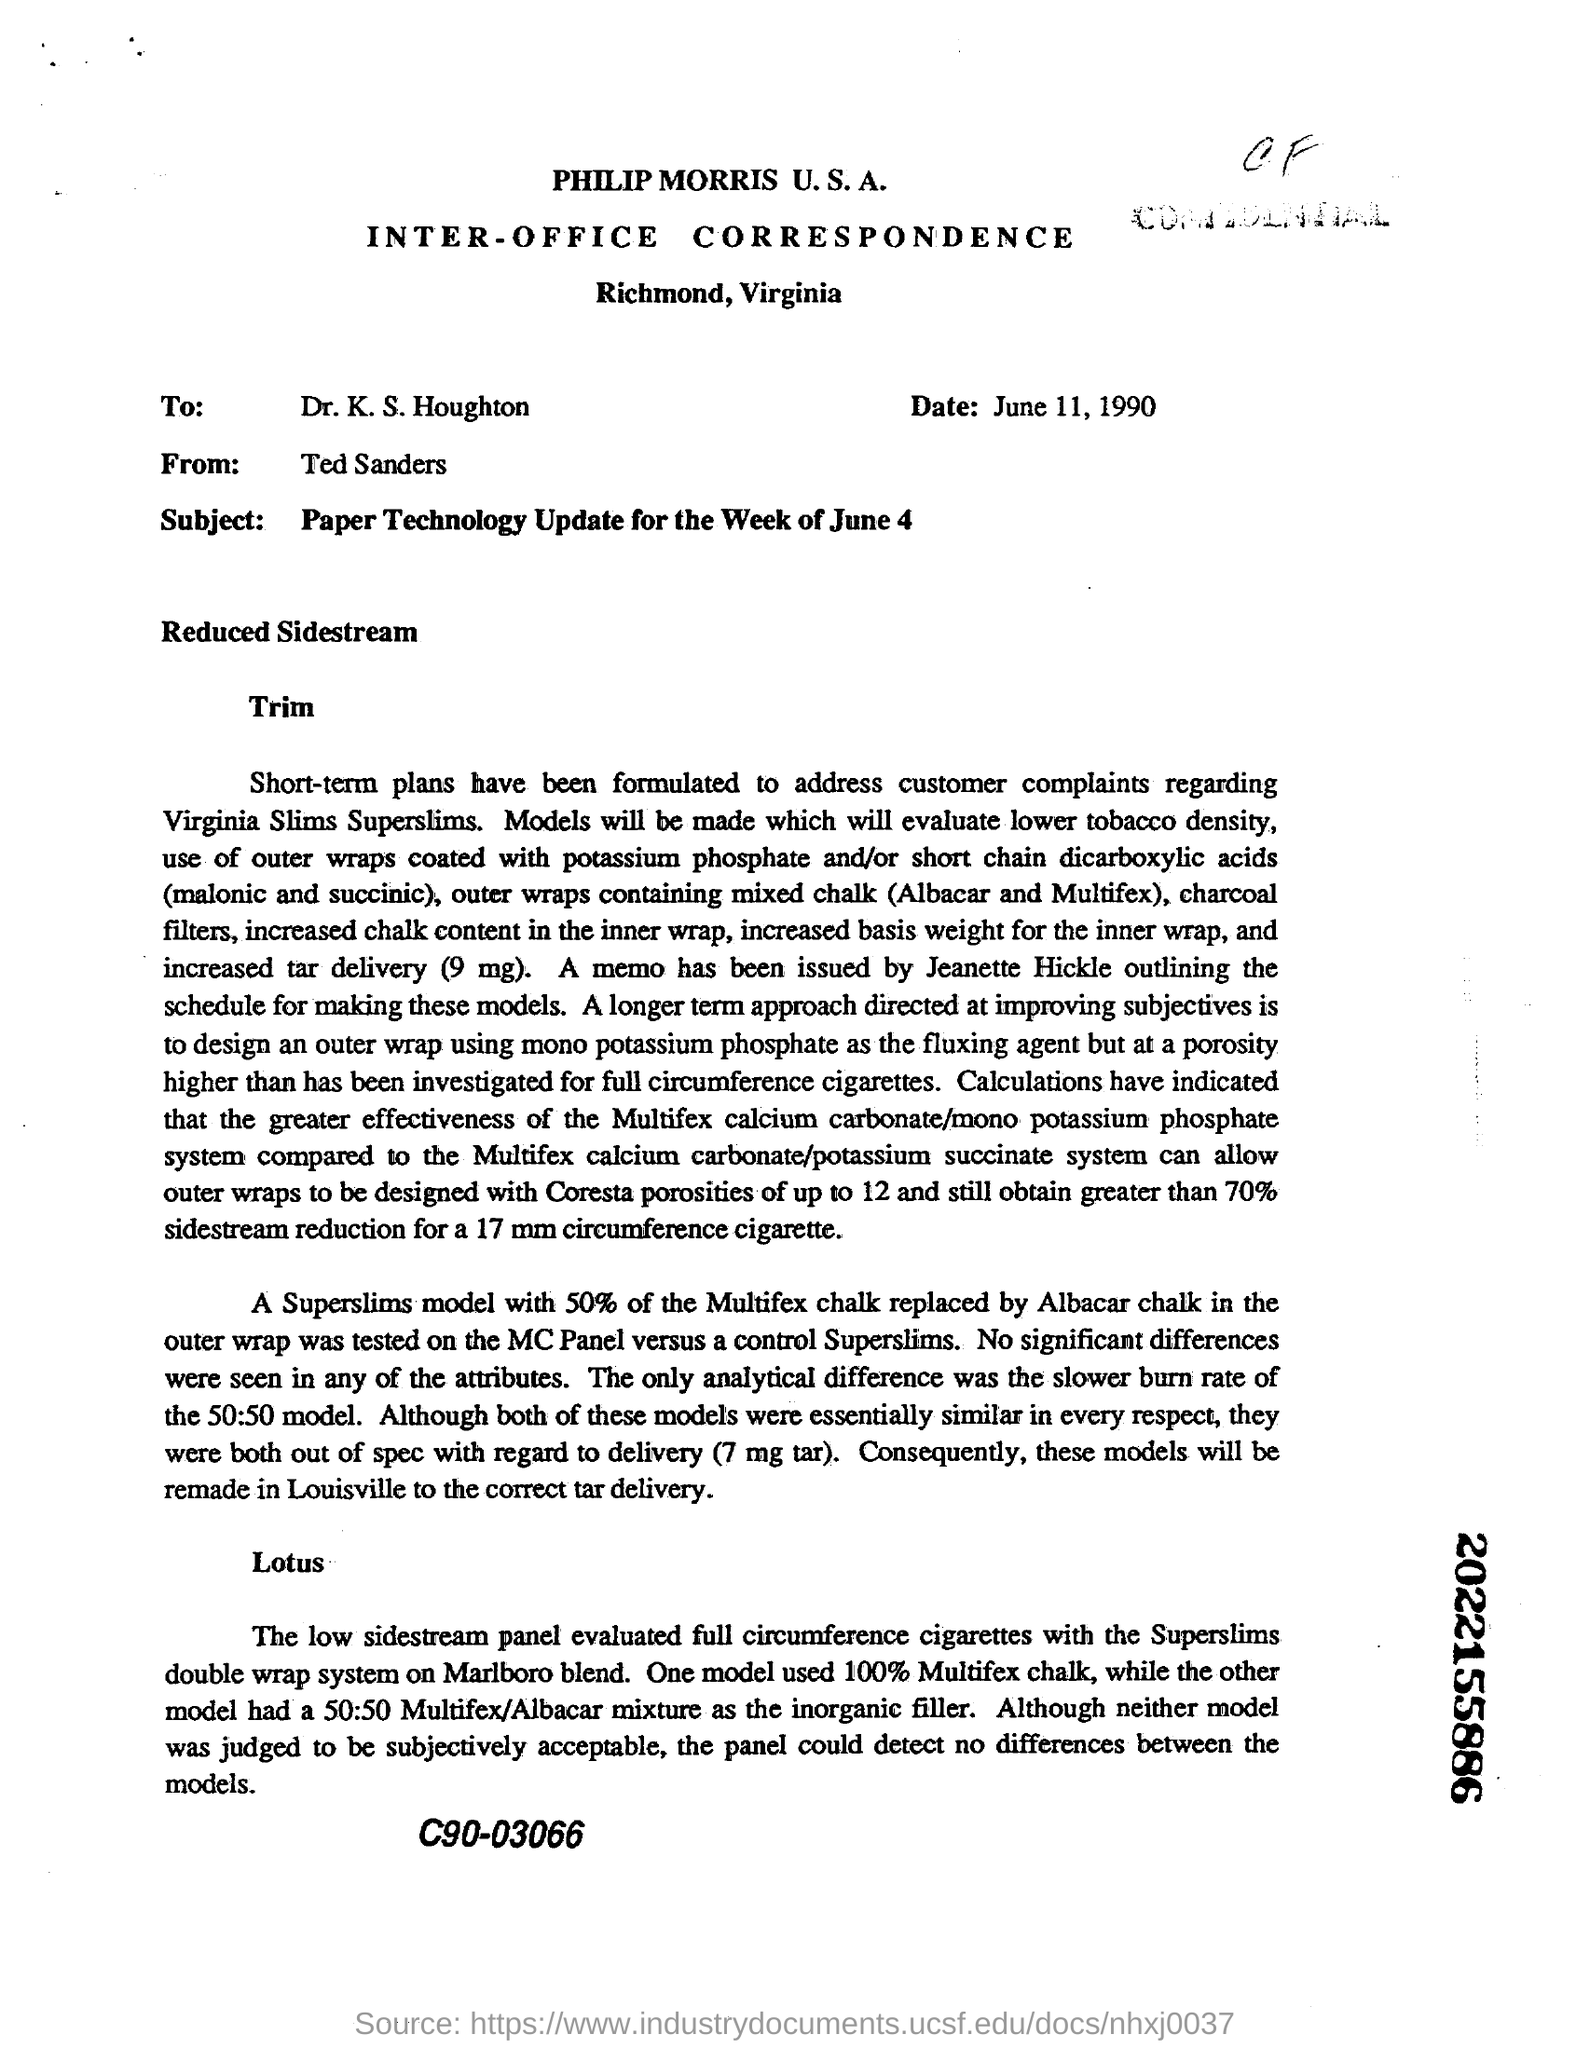Point out several critical features in this image. To whom this letter is addressed: Dr. K.S. Houghton. The letter was sent from Richmond, which is located in Virginia. Ted Sanders sent the letter. The date mentioned in the letter is June 11, 1990. 